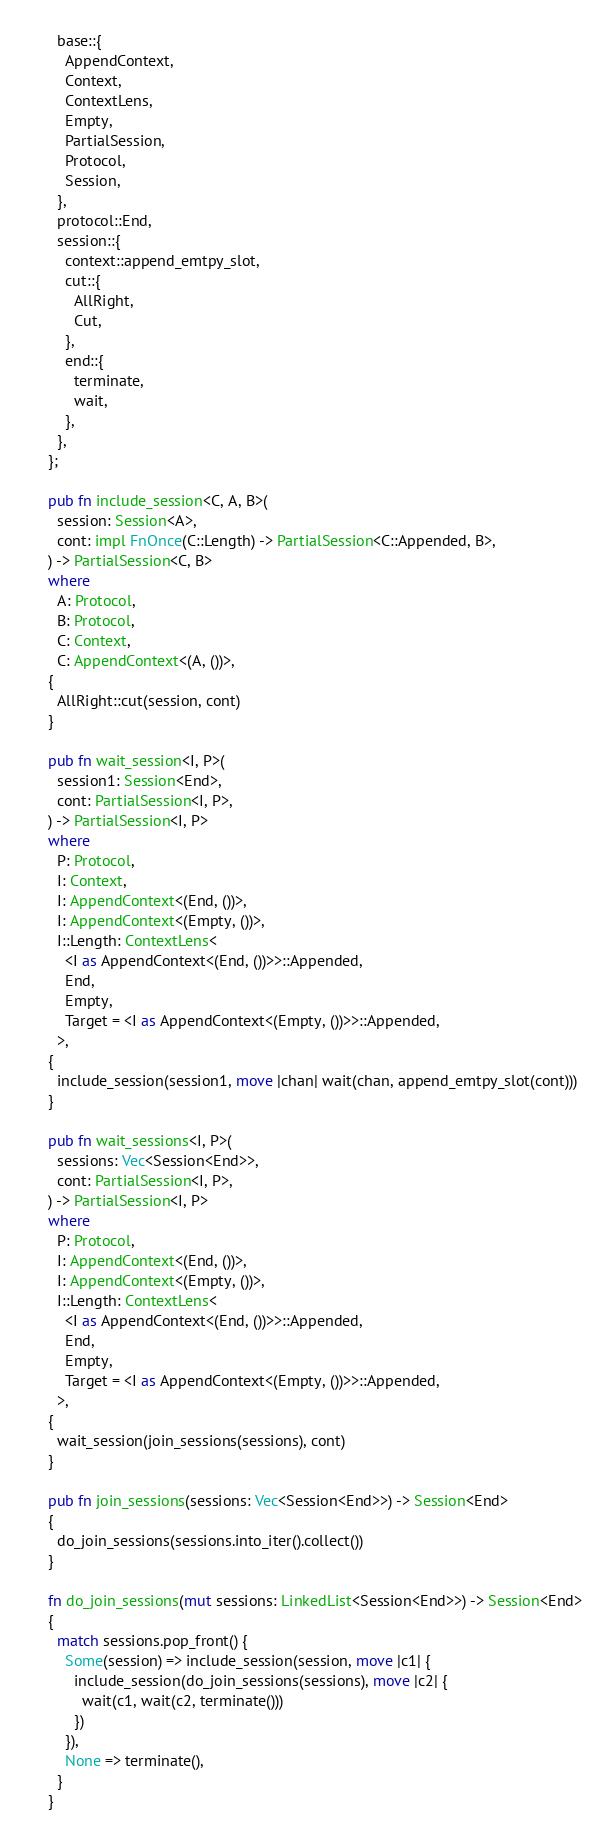Convert code to text. <code><loc_0><loc_0><loc_500><loc_500><_Rust_>  base::{
    AppendContext,
    Context,
    ContextLens,
    Empty,
    PartialSession,
    Protocol,
    Session,
  },
  protocol::End,
  session::{
    context::append_emtpy_slot,
    cut::{
      AllRight,
      Cut,
    },
    end::{
      terminate,
      wait,
    },
  },
};

pub fn include_session<C, A, B>(
  session: Session<A>,
  cont: impl FnOnce(C::Length) -> PartialSession<C::Appended, B>,
) -> PartialSession<C, B>
where
  A: Protocol,
  B: Protocol,
  C: Context,
  C: AppendContext<(A, ())>,
{
  AllRight::cut(session, cont)
}

pub fn wait_session<I, P>(
  session1: Session<End>,
  cont: PartialSession<I, P>,
) -> PartialSession<I, P>
where
  P: Protocol,
  I: Context,
  I: AppendContext<(End, ())>,
  I: AppendContext<(Empty, ())>,
  I::Length: ContextLens<
    <I as AppendContext<(End, ())>>::Appended,
    End,
    Empty,
    Target = <I as AppendContext<(Empty, ())>>::Appended,
  >,
{
  include_session(session1, move |chan| wait(chan, append_emtpy_slot(cont)))
}

pub fn wait_sessions<I, P>(
  sessions: Vec<Session<End>>,
  cont: PartialSession<I, P>,
) -> PartialSession<I, P>
where
  P: Protocol,
  I: AppendContext<(End, ())>,
  I: AppendContext<(Empty, ())>,
  I::Length: ContextLens<
    <I as AppendContext<(End, ())>>::Appended,
    End,
    Empty,
    Target = <I as AppendContext<(Empty, ())>>::Appended,
  >,
{
  wait_session(join_sessions(sessions), cont)
}

pub fn join_sessions(sessions: Vec<Session<End>>) -> Session<End>
{
  do_join_sessions(sessions.into_iter().collect())
}

fn do_join_sessions(mut sessions: LinkedList<Session<End>>) -> Session<End>
{
  match sessions.pop_front() {
    Some(session) => include_session(session, move |c1| {
      include_session(do_join_sessions(sessions), move |c2| {
        wait(c1, wait(c2, terminate()))
      })
    }),
    None => terminate(),
  }
}
</code> 